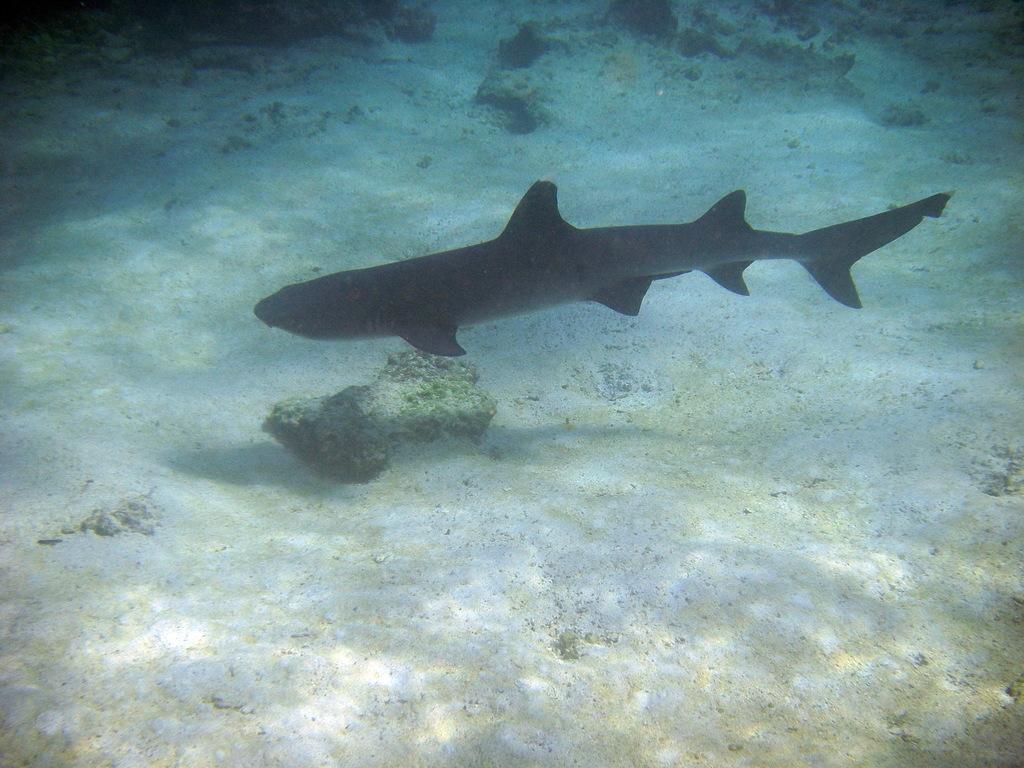Please provide a concise description of this image. In this picture there is a fish in the water. At the bottom there is sand and there are stones. 